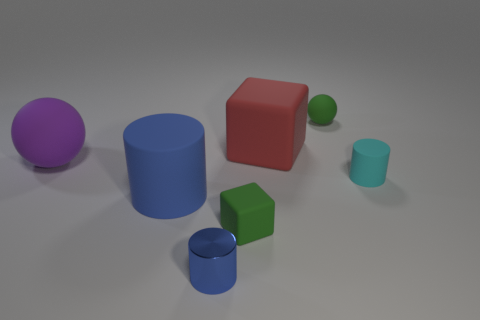Are there any objects in the image that seem out of place or different from the others? All objects in the image seem to be deliberately placed and none appear out of place. However, if we consider the color and shape pairings, the smaller blue cylinder is unique since it is the only object that shares its color with another object (the larger blue cylinder), suggesting a connection or relationship between them. 